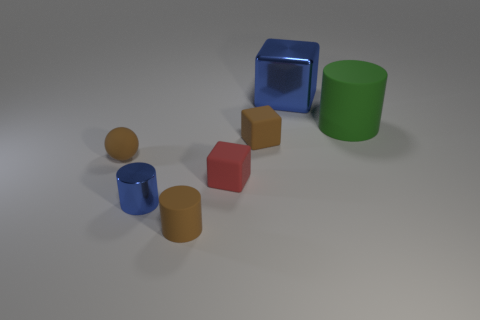How many things are either brown objects in front of the small metal cylinder or red things?
Your answer should be very brief. 2. Are there an equal number of small brown matte spheres in front of the large blue object and metallic blocks?
Give a very brief answer. Yes. Is the color of the shiny cylinder the same as the large matte thing?
Your answer should be very brief. No. What color is the cube that is behind the red rubber block and in front of the big blue metallic block?
Your response must be concise. Brown. How many cylinders are either small blue metal things or small yellow matte things?
Make the answer very short. 1. Is the number of red rubber blocks that are to the right of the small red rubber thing less than the number of spheres?
Provide a short and direct response. Yes. There is a big green thing that is made of the same material as the tiny ball; what is its shape?
Offer a very short reply. Cylinder. How many tiny blocks have the same color as the matte ball?
Make the answer very short. 1. What number of objects are either big blue objects or cubes?
Offer a very short reply. 3. What material is the tiny block behind the small block in front of the tiny ball?
Keep it short and to the point. Rubber. 